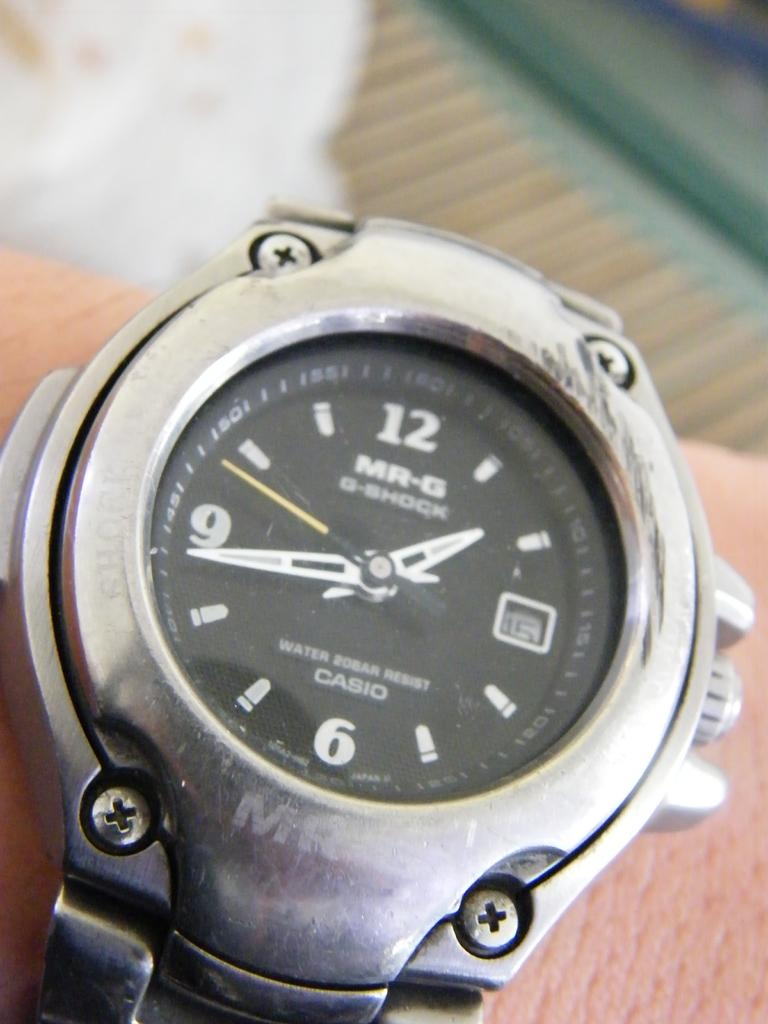<image>
Present a compact description of the photo's key features. Person wearing a watch which has a black face and the word CASIO on it. 